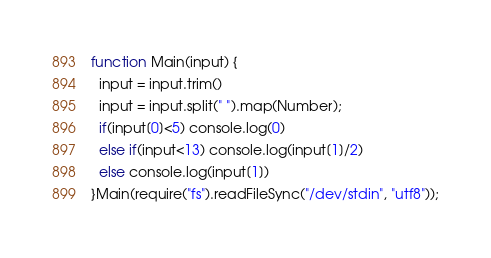Convert code to text. <code><loc_0><loc_0><loc_500><loc_500><_JavaScript_>function Main(input) {
  input = input.trim()
  input = input.split(" ").map(Number);
  if(input[0]<5) console.log(0)
  else if(input<13) console.log(input[1]/2)
  else console.log(input[1])
}Main(require("fs").readFileSync("/dev/stdin", "utf8"));</code> 